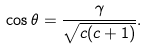Convert formula to latex. <formula><loc_0><loc_0><loc_500><loc_500>\cos \theta = \frac { \gamma } { \sqrt { c ( c + 1 ) } } .</formula> 